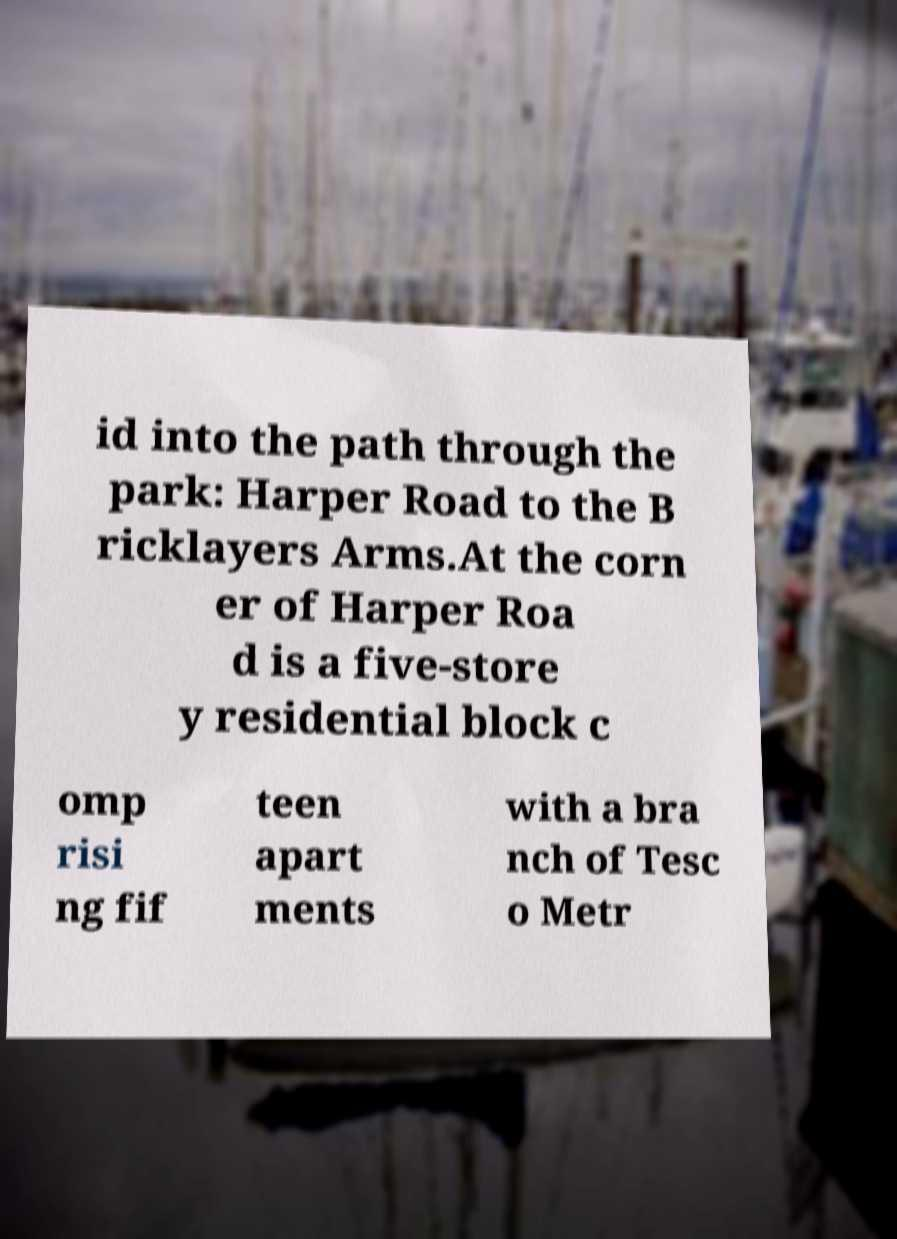Please read and relay the text visible in this image. What does it say? id into the path through the park: Harper Road to the B ricklayers Arms.At the corn er of Harper Roa d is a five-store y residential block c omp risi ng fif teen apart ments with a bra nch of Tesc o Metr 